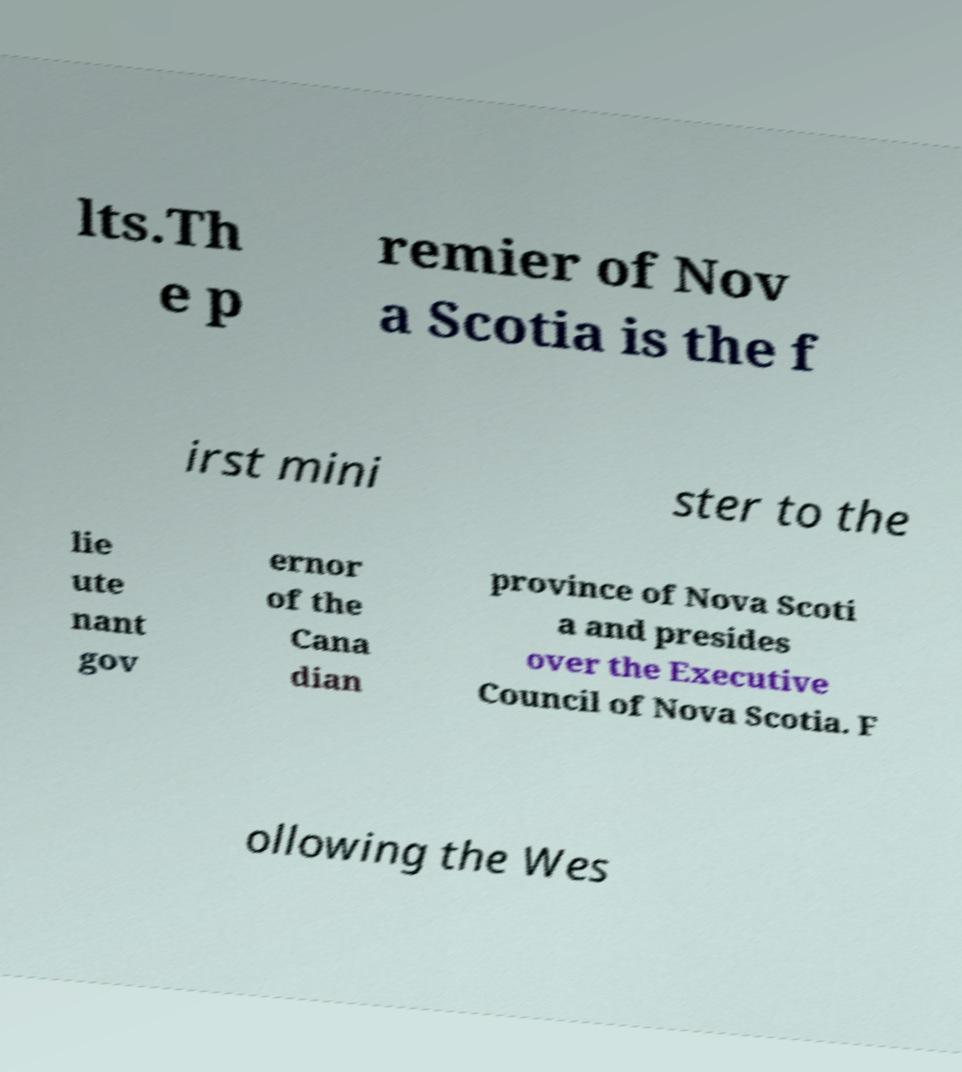I need the written content from this picture converted into text. Can you do that? lts.Th e p remier of Nov a Scotia is the f irst mini ster to the lie ute nant gov ernor of the Cana dian province of Nova Scoti a and presides over the Executive Council of Nova Scotia. F ollowing the Wes 